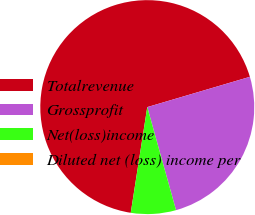<chart> <loc_0><loc_0><loc_500><loc_500><pie_chart><fcel>Totalrevenue<fcel>Grossprofit<fcel>Net(loss)income<fcel>Diluted net (loss) income per<nl><fcel>67.97%<fcel>25.24%<fcel>6.8%<fcel>0.0%<nl></chart> 